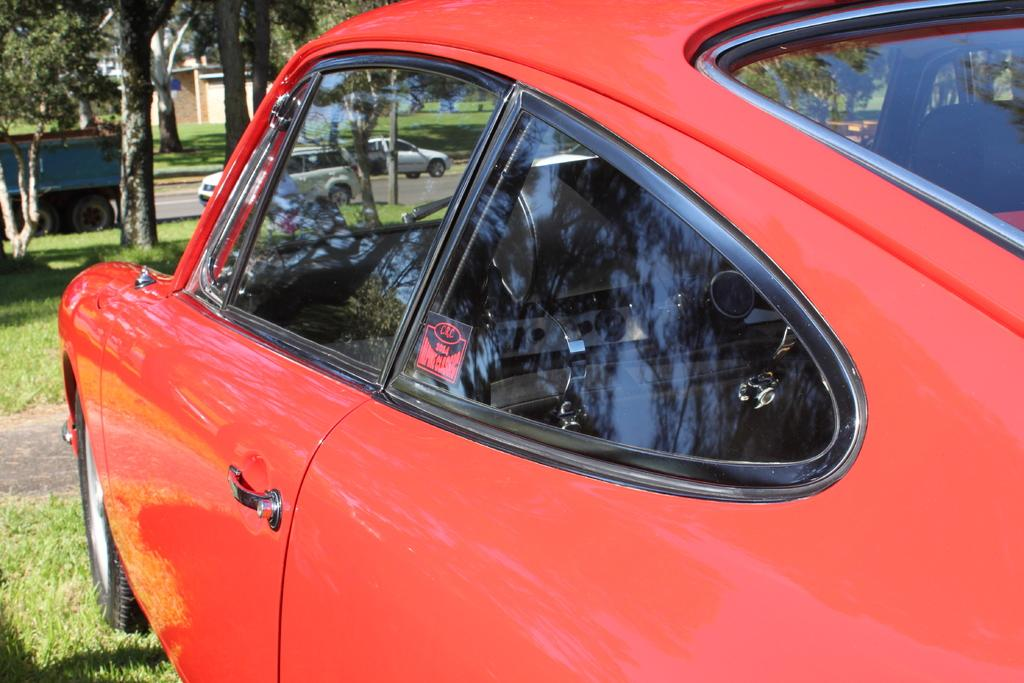What is the main subject of the image? There is a car in the image. What type of terrain is visible in the image? There is grass on the ground in the image. What can be seen in the background of the image? There are trees, a road, other vehicles, and a building visible in the background of the image. Can you see any giraffes or icicles in the image? No, there are no giraffes or icicles present in the image. Is there any rice visible in the image? No, there is no rice visible in the image. 